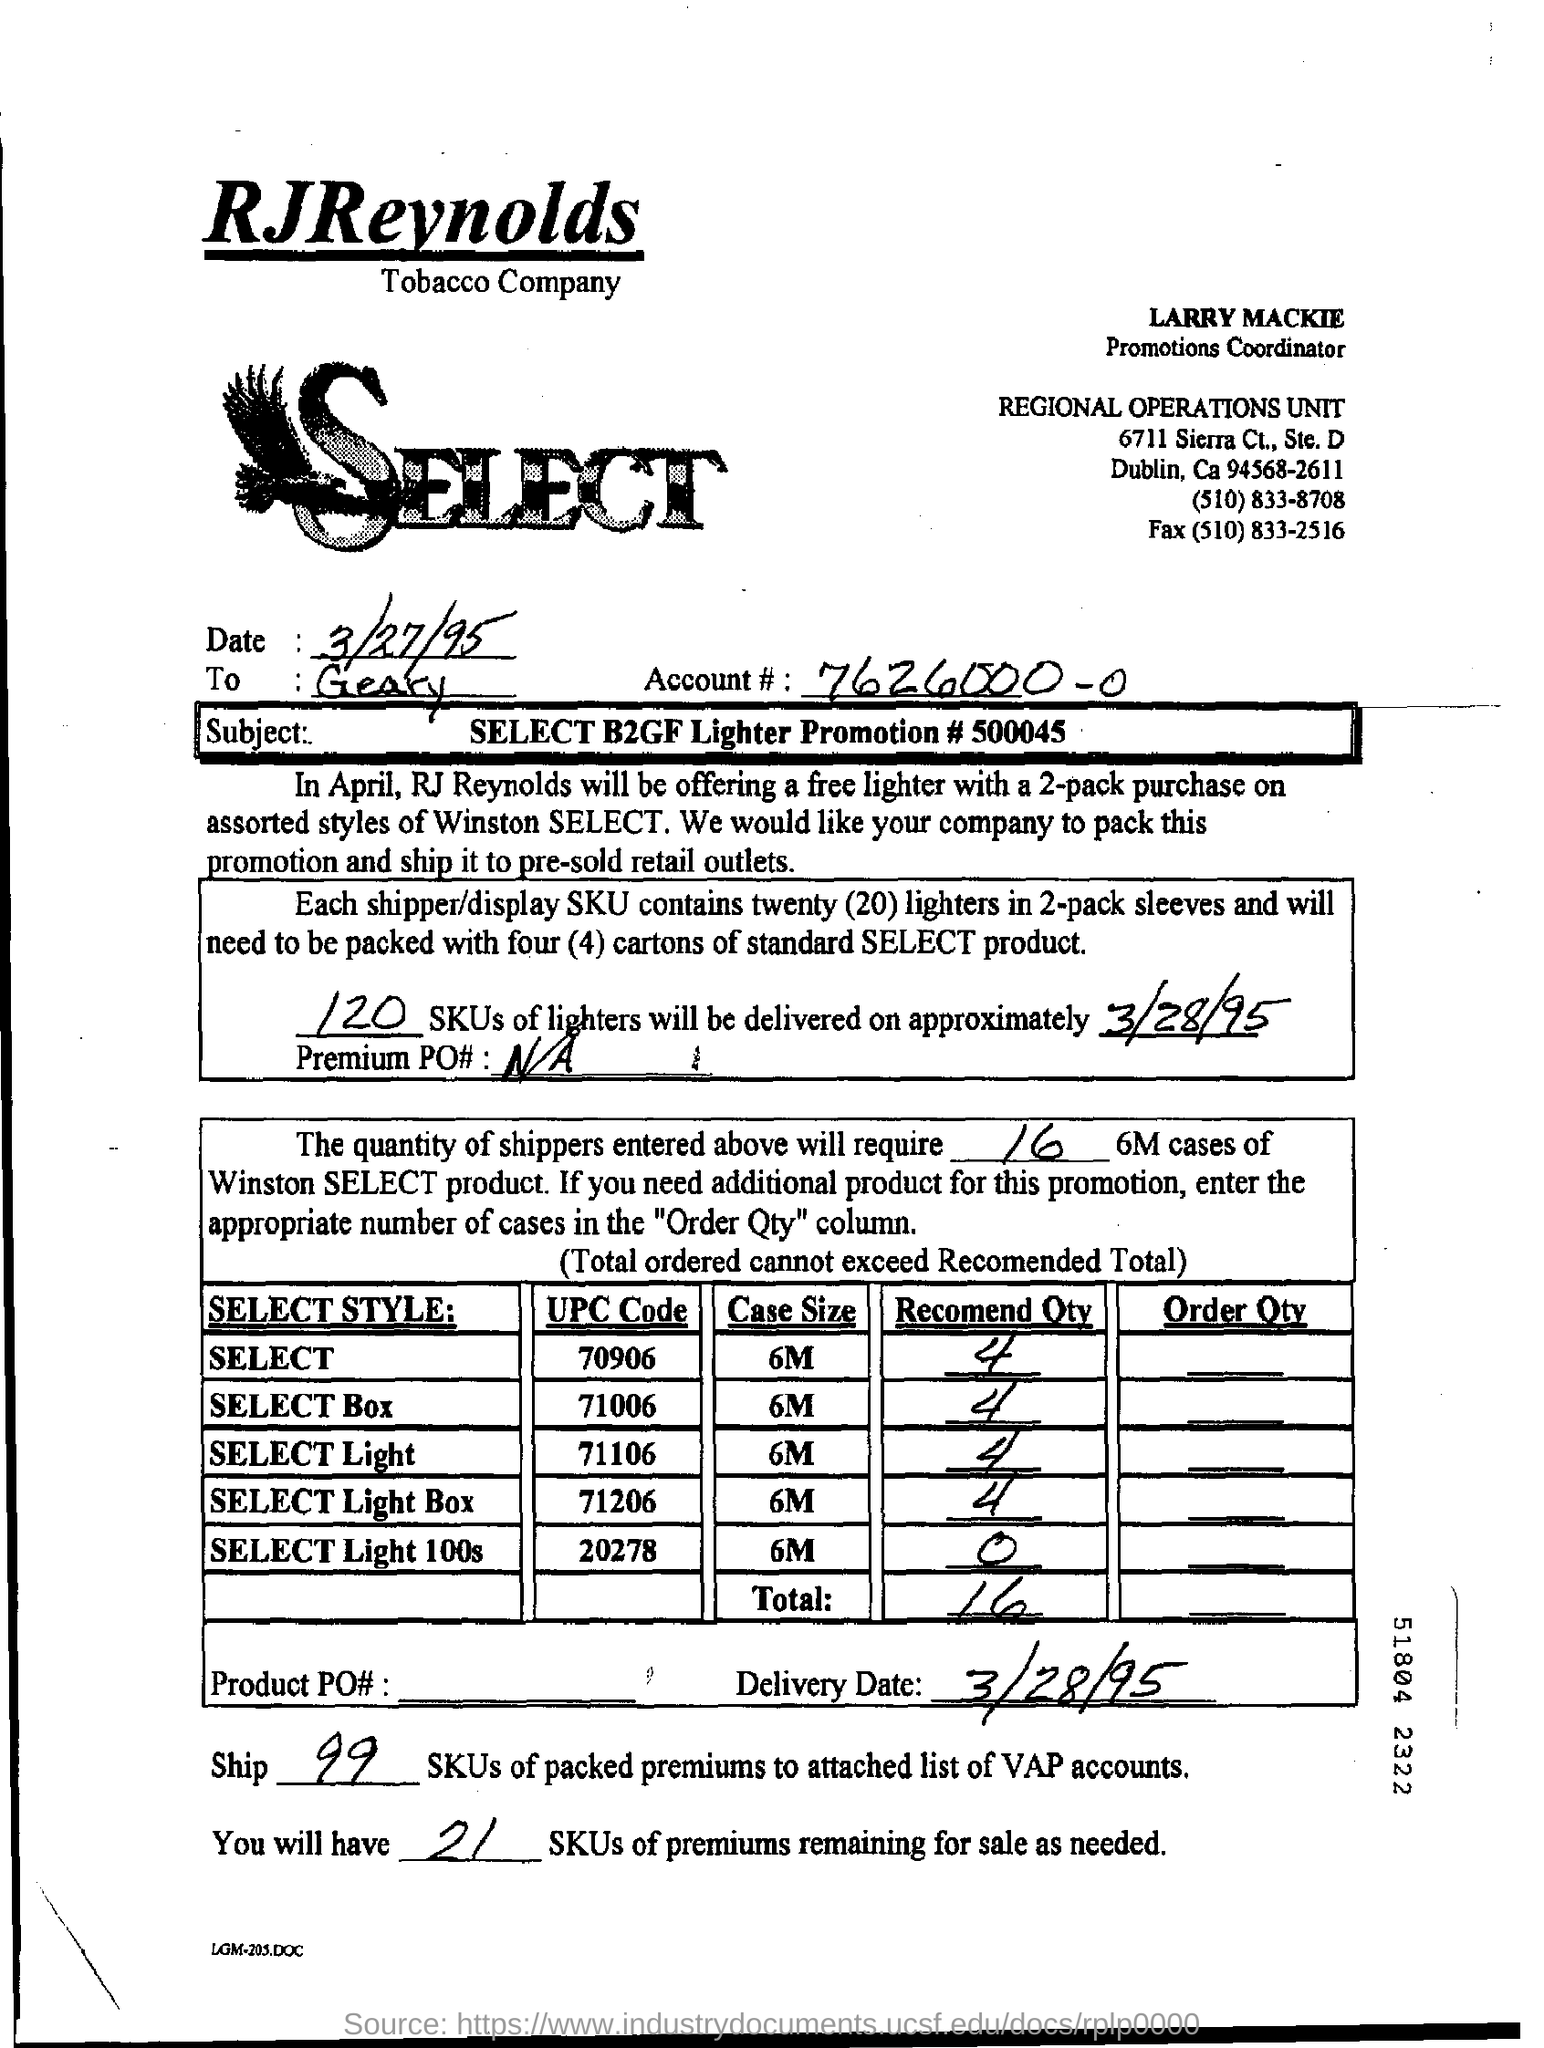What is the Account #?
Make the answer very short. 7626000-0. How many SKUs of lighters will be delivered?
Provide a succinct answer. 120. What is the Delivery Date?
Offer a terse response. 3/28/95. What is the Fax for Regional Operations Unit?
Offer a very short reply. (510) 833-2516. 